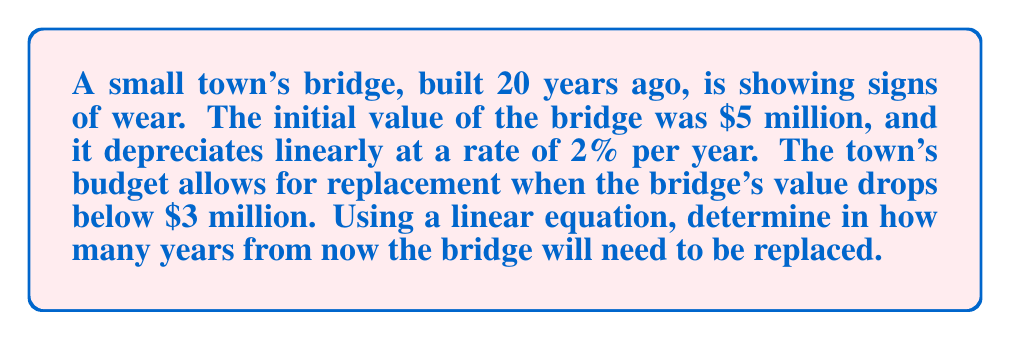Could you help me with this problem? Let's approach this step-by-step:

1) First, we need to set up our linear equation. The general form is:
   $$y = mx + b$$
   where $y$ is the value, $m$ is the slope (rate of change), $x$ is the time, and $b$ is the initial value.

2) We know:
   - Initial value (b) = $5 million
   - Rate of depreciation = 2% per year = 0.02
   - The slope (m) is negative because the value is decreasing: m = -0.02 * $5 million = -$100,000 per year

3) Our equation becomes:
   $$y = -100,000x + 5,000,000$$

4) We want to find when y = $3 million (the replacement threshold). So we solve:
   $$3,000,000 = -100,000x + 5,000,000$$

5) Subtracting 5,000,000 from both sides:
   $$-2,000,000 = -100,000x$$

6) Dividing both sides by -100,000:
   $$20 = x$$

7) This means the bridge will reach $3 million in value after 20 years.

8) However, the bridge is already 20 years old. So we need to subtract 20 from our result:
   $$20 - 20 = 0$$

Therefore, the bridge needs to be replaced immediately (0 years from now).
Answer: 0 years 